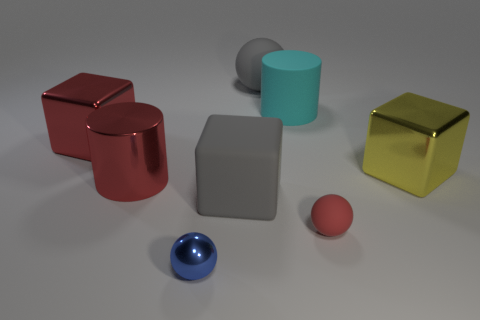What is the color of the cylinder that is behind the big metallic cube on the left side of the small red rubber sphere that is on the right side of the big red metal cylinder?
Provide a succinct answer. Cyan. Do the red cylinder and the large red thing behind the big yellow shiny cube have the same material?
Your answer should be very brief. Yes. What size is the red object that is the same shape as the blue metal object?
Make the answer very short. Small. Are there the same number of yellow blocks on the left side of the large gray block and red objects that are on the right side of the small rubber object?
Your answer should be compact. Yes. How many other things are there of the same material as the large cyan cylinder?
Provide a succinct answer. 3. Are there an equal number of large yellow blocks that are behind the large ball and blocks?
Your answer should be compact. No. There is a red sphere; is it the same size as the gray matte object behind the big yellow block?
Provide a succinct answer. No. What is the shape of the gray matte object behind the large red metallic block?
Your response must be concise. Sphere. Is there anything else that is the same shape as the yellow thing?
Your answer should be very brief. Yes. Is the number of large rubber spheres the same as the number of tiny green rubber balls?
Your response must be concise. No. 